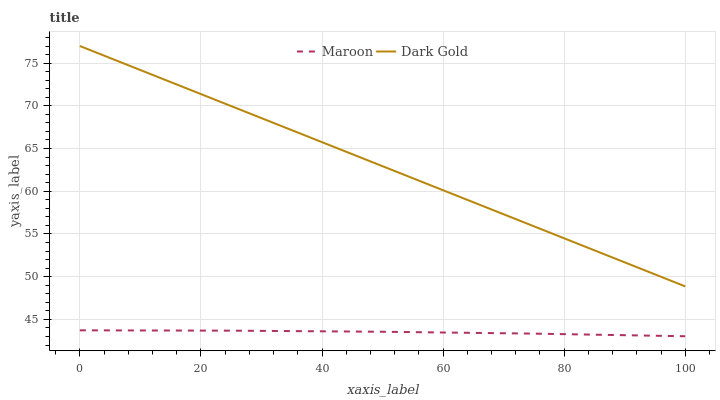Does Maroon have the minimum area under the curve?
Answer yes or no. Yes. Does Dark Gold have the maximum area under the curve?
Answer yes or no. Yes. Does Dark Gold have the minimum area under the curve?
Answer yes or no. No. Is Dark Gold the smoothest?
Answer yes or no. Yes. Is Maroon the roughest?
Answer yes or no. Yes. Is Dark Gold the roughest?
Answer yes or no. No. Does Maroon have the lowest value?
Answer yes or no. Yes. Does Dark Gold have the lowest value?
Answer yes or no. No. Does Dark Gold have the highest value?
Answer yes or no. Yes. Is Maroon less than Dark Gold?
Answer yes or no. Yes. Is Dark Gold greater than Maroon?
Answer yes or no. Yes. Does Maroon intersect Dark Gold?
Answer yes or no. No. 